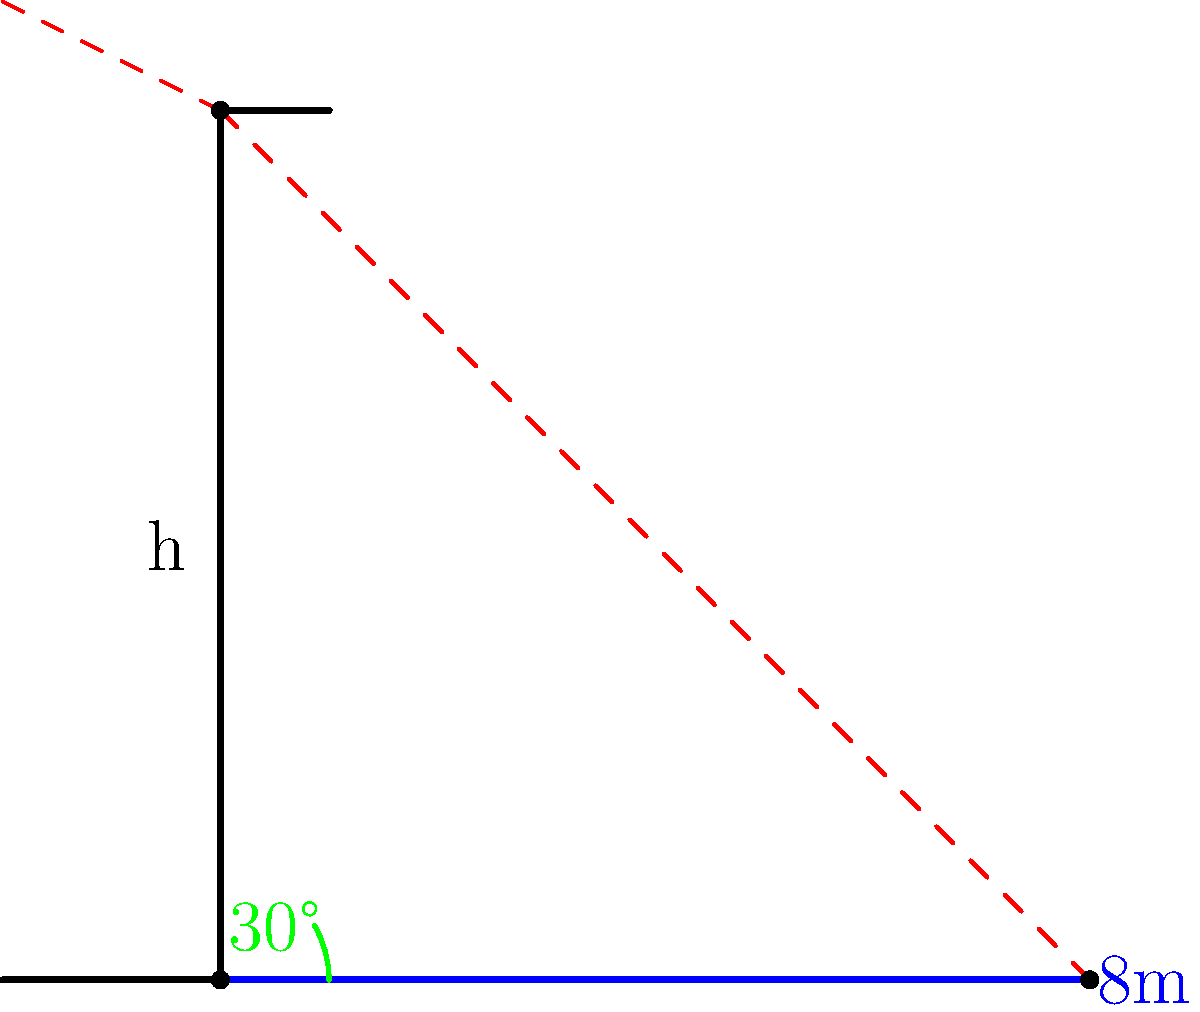As a preservationist of historical sites, you're tasked with estimating the height of a colonial-era building. Using a sundial, you determine that the sun's angle is 30° above the horizon. If the building's shadow extends 8 meters from its base, what is the approximate height of the building? To solve this problem, we'll use trigonometry:

1) In a right triangle formed by the building, its shadow, and the sun's rays, we know:
   - The angle of elevation of the sun: 30°
   - The length of the shadow: 8 meters
   - We need to find the height of the building

2) The tangent of an angle in a right triangle is the ratio of the opposite side to the adjacent side.
   In this case: $\tan(30°) = \frac{\text{height}}{\text{shadow length}}$

3) We can express this as an equation:
   $\tan(30°) = \frac{h}{8}$, where $h$ is the height of the building

4) Solving for $h$:
   $h = 8 \times \tan(30°)$

5) We know that $\tan(30°) = \frac{1}{\sqrt{3}} \approx 0.577$

6) Therefore:
   $h = 8 \times 0.577 \approx 4.62$ meters

7) Rounding to the nearest decimeter for practical purposes:
   $h \approx 4.6$ meters
Answer: $4.6$ meters 